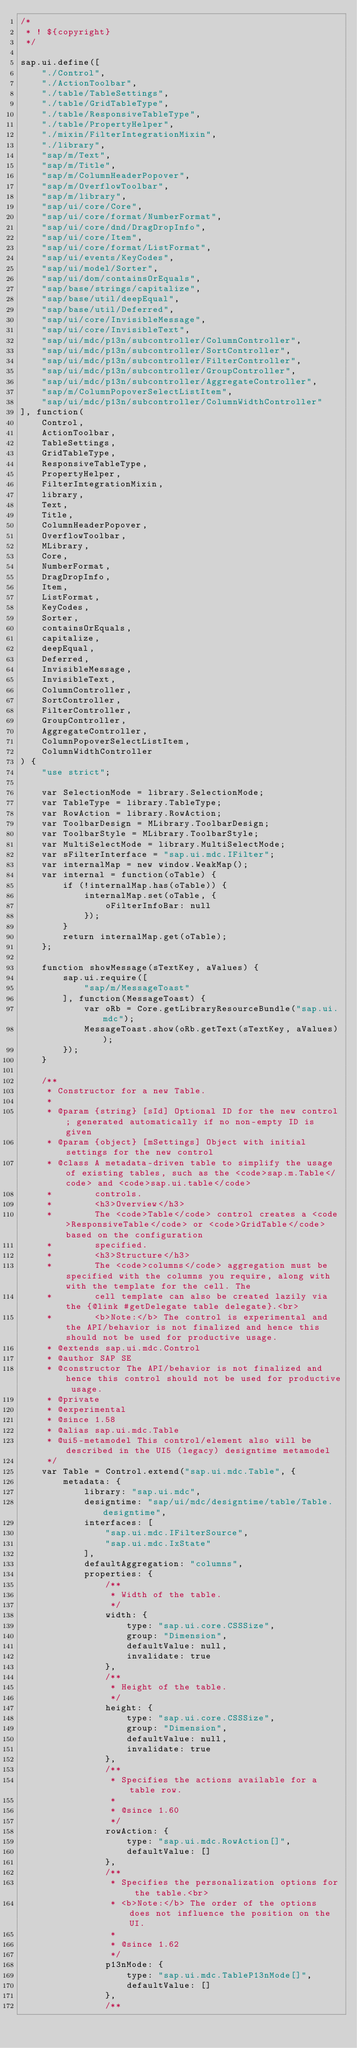Convert code to text. <code><loc_0><loc_0><loc_500><loc_500><_JavaScript_>/*
 * ! ${copyright}
 */

sap.ui.define([
	"./Control",
	"./ActionToolbar",
	"./table/TableSettings",
	"./table/GridTableType",
	"./table/ResponsiveTableType",
	"./table/PropertyHelper",
	"./mixin/FilterIntegrationMixin",
	"./library",
	"sap/m/Text",
	"sap/m/Title",
	"sap/m/ColumnHeaderPopover",
	"sap/m/OverflowToolbar",
	"sap/m/library",
	"sap/ui/core/Core",
	"sap/ui/core/format/NumberFormat",
	"sap/ui/core/dnd/DragDropInfo",
	"sap/ui/core/Item",
	"sap/ui/core/format/ListFormat",
	"sap/ui/events/KeyCodes",
	"sap/ui/model/Sorter",
	"sap/ui/dom/containsOrEquals",
	"sap/base/strings/capitalize",
	"sap/base/util/deepEqual",
	"sap/base/util/Deferred",
	"sap/ui/core/InvisibleMessage",
	"sap/ui/core/InvisibleText",
	"sap/ui/mdc/p13n/subcontroller/ColumnController",
	"sap/ui/mdc/p13n/subcontroller/SortController",
	"sap/ui/mdc/p13n/subcontroller/FilterController",
	"sap/ui/mdc/p13n/subcontroller/GroupController",
	"sap/ui/mdc/p13n/subcontroller/AggregateController",
	"sap/m/ColumnPopoverSelectListItem",
	"sap/ui/mdc/p13n/subcontroller/ColumnWidthController"
], function(
	Control,
	ActionToolbar,
	TableSettings,
	GridTableType,
	ResponsiveTableType,
	PropertyHelper,
	FilterIntegrationMixin,
	library,
	Text,
	Title,
	ColumnHeaderPopover,
	OverflowToolbar,
	MLibrary,
	Core,
	NumberFormat,
	DragDropInfo,
	Item,
	ListFormat,
	KeyCodes,
	Sorter,
	containsOrEquals,
	capitalize,
	deepEqual,
	Deferred,
	InvisibleMessage,
	InvisibleText,
	ColumnController,
	SortController,
	FilterController,
	GroupController,
	AggregateController,
	ColumnPopoverSelectListItem,
	ColumnWidthController
) {
	"use strict";

	var SelectionMode = library.SelectionMode;
	var TableType = library.TableType;
	var RowAction = library.RowAction;
	var ToolbarDesign = MLibrary.ToolbarDesign;
	var ToolbarStyle = MLibrary.ToolbarStyle;
	var MultiSelectMode = library.MultiSelectMode;
	var sFilterInterface = "sap.ui.mdc.IFilter";
	var internalMap = new window.WeakMap();
	var internal = function(oTable) {
		if (!internalMap.has(oTable)) {
			internalMap.set(oTable, {
				oFilterInfoBar: null
			});
		}
		return internalMap.get(oTable);
	};

	function showMessage(sTextKey, aValues) {
		sap.ui.require([
			"sap/m/MessageToast"
		], function(MessageToast) {
			var oRb = Core.getLibraryResourceBundle("sap.ui.mdc");
			MessageToast.show(oRb.getText(sTextKey, aValues));
		});
	}

	/**
	 * Constructor for a new Table.
	 *
	 * @param {string} [sId] Optional ID for the new control; generated automatically if no non-empty ID is given
	 * @param {object} [mSettings] Object with initial settings for the new control
	 * @class A metadata-driven table to simplify the usage of existing tables, such as the <code>sap.m.Table</code> and <code>sap.ui.table</code>
	 *        controls.
	 *        <h3>Overview</h3>
	 *        The <code>Table</code> control creates a <code>ResponsiveTable</code> or <code>GridTable</code> based on the configuration
	 *        specified.
	 *        <h3>Structure</h3>
	 *        The <code>columns</code> aggregation must be specified with the columns you require, along with with the template for the cell. The
	 *        cell template can also be created lazily via the {@link #getDelegate table delegate}.<br>
	 *        <b>Note:</b> The control is experimental and the API/behavior is not finalized and hence this should not be used for productive usage.
	 * @extends sap.ui.mdc.Control
	 * @author SAP SE
	 * @constructor The API/behavior is not finalized and hence this control should not be used for productive usage.
	 * @private
	 * @experimental
	 * @since 1.58
	 * @alias sap.ui.mdc.Table
	 * @ui5-metamodel This control/element also will be described in the UI5 (legacy) designtime metamodel
	 */
	var Table = Control.extend("sap.ui.mdc.Table", {
		metadata: {
			library: "sap.ui.mdc",
			designtime: "sap/ui/mdc/designtime/table/Table.designtime",
			interfaces: [
				"sap.ui.mdc.IFilterSource",
				"sap.ui.mdc.IxState"
			],
			defaultAggregation: "columns",
			properties: {
				/**
				 * Width of the table.
				 */
				width: {
					type: "sap.ui.core.CSSSize",
					group: "Dimension",
					defaultValue: null,
					invalidate: true
				},
				/**
				 * Height of the table.
				 */
				height: {
					type: "sap.ui.core.CSSSize",
					group: "Dimension",
					defaultValue: null,
					invalidate: true
				},
				/**
				 * Specifies the actions available for a table row.
				 *
				 * @since 1.60
				 */
				rowAction: {
					type: "sap.ui.mdc.RowAction[]",
					defaultValue: []
				},
				/**
				 * Specifies the personalization options for the table.<br>
				 * <b>Note:</b> The order of the options does not influence the position on the UI.
				 *
				 * @since 1.62
				 */
				p13nMode: {
					type: "sap.ui.mdc.TableP13nMode[]",
					defaultValue: []
				},
				/**</code> 